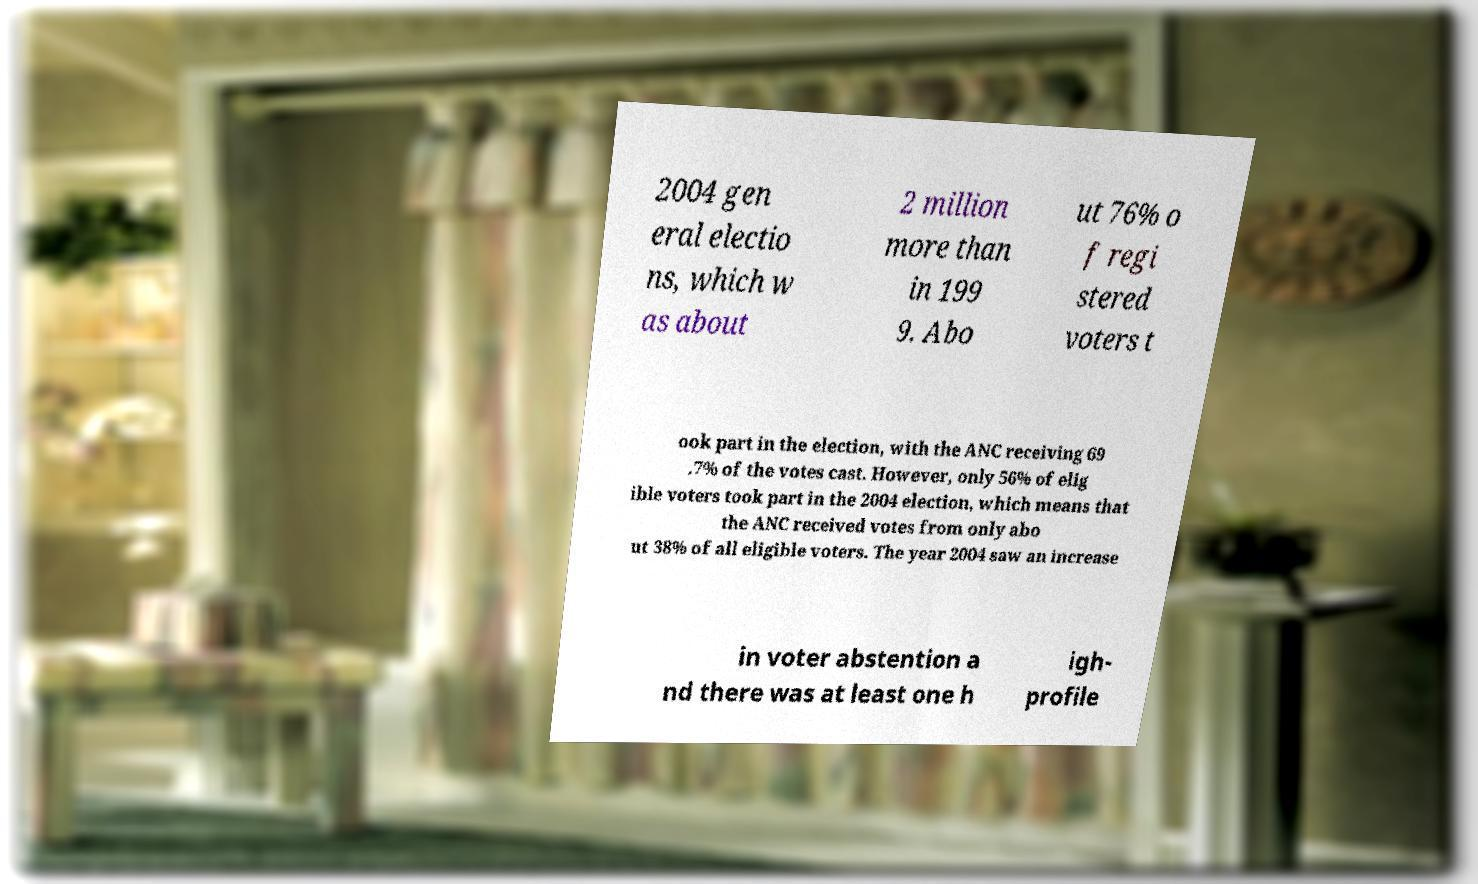Can you accurately transcribe the text from the provided image for me? 2004 gen eral electio ns, which w as about 2 million more than in 199 9. Abo ut 76% o f regi stered voters t ook part in the election, with the ANC receiving 69 .7% of the votes cast. However, only 56% of elig ible voters took part in the 2004 election, which means that the ANC received votes from only abo ut 38% of all eligible voters. The year 2004 saw an increase in voter abstention a nd there was at least one h igh- profile 